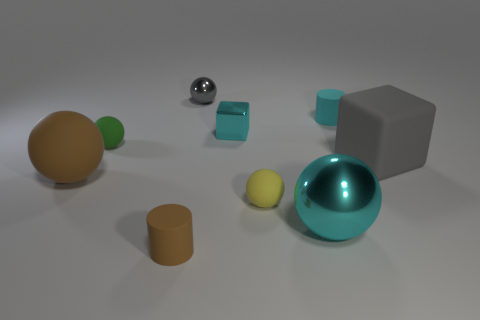What color is the cylinder that is behind the tiny metal object that is on the right side of the gray thing left of the small cyan cube?
Your response must be concise. Cyan. Are the gray object that is to the left of the yellow matte ball and the big brown object made of the same material?
Your response must be concise. No. Are there any other big cubes of the same color as the metallic block?
Your answer should be very brief. No. Are there any small cyan things?
Offer a very short reply. Yes. Does the cylinder that is to the right of the brown cylinder have the same size as the gray metallic thing?
Offer a very short reply. Yes. Is the number of cyan spheres less than the number of red metal things?
Provide a short and direct response. No. What is the shape of the cyan thing that is in front of the small rubber ball left of the matte sphere to the right of the tiny metal cube?
Your response must be concise. Sphere. Are there any brown balls that have the same material as the big cyan object?
Offer a terse response. No. Is the color of the small thing right of the big cyan ball the same as the rubber cylinder that is in front of the cyan metallic ball?
Offer a very short reply. No. Are there fewer gray matte things right of the cyan sphere than cylinders?
Your answer should be compact. Yes. 